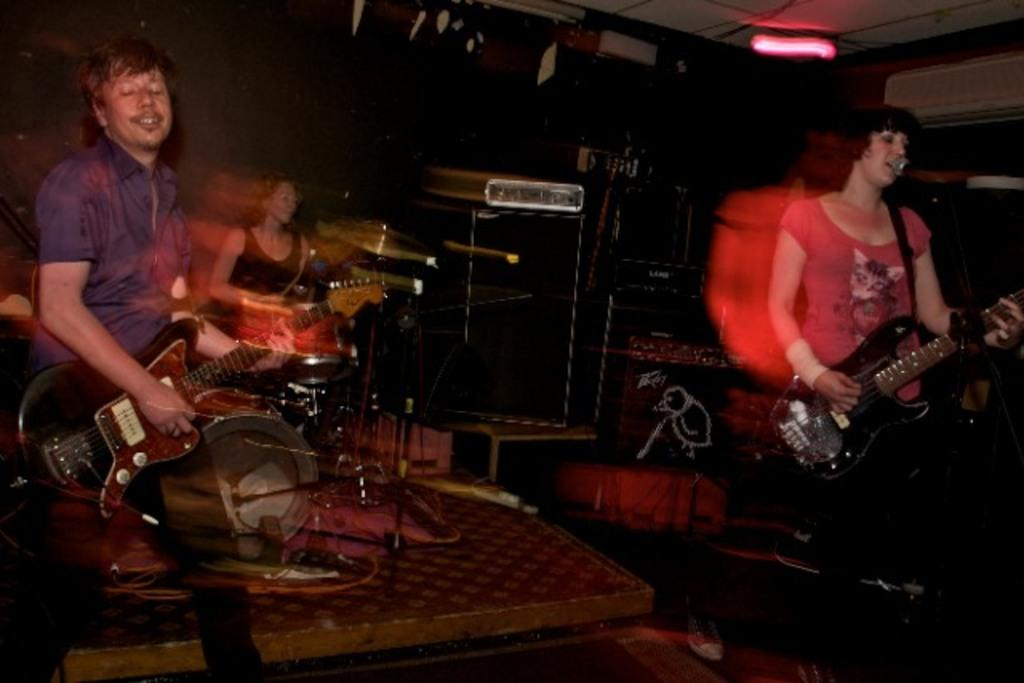What are the people in the image doing? The people in the image are playing musical instruments. What can be seen behind the people in the image? There is a wall in the background of the image. What is above the people in the image? There is a ceiling at the top of the image. Can you describe the lighting in the image? There is a light visible in the image. Can you see any branches in the image? There are no branches visible in the image. How many times do the people kick the ball during their performance? There is no ball present in the image, so it is not possible to determine how many times they kick it. 